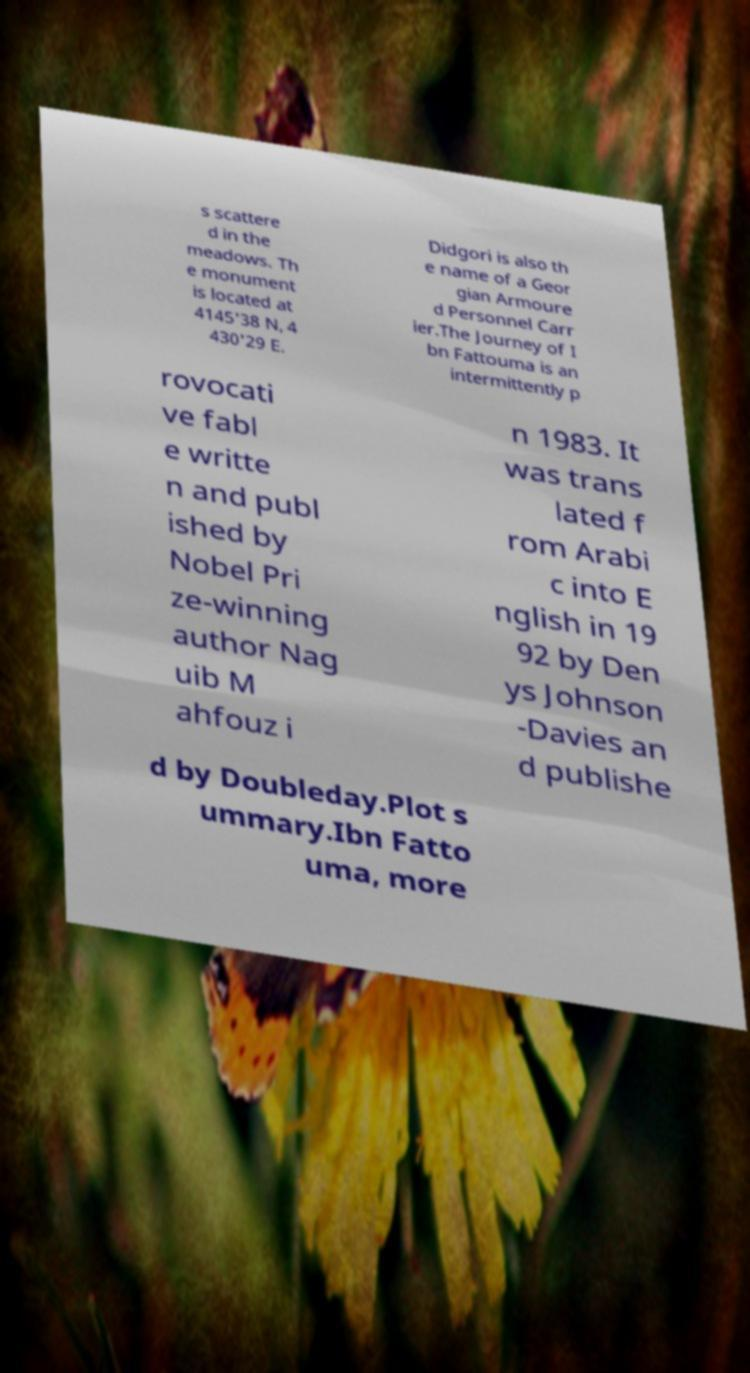Please read and relay the text visible in this image. What does it say? s scattere d in the meadows. Th e monument is located at 4145'38 N, 4 430'29 E. Didgori is also th e name of a Geor gian Armoure d Personnel Carr ier.The Journey of I bn Fattouma is an intermittently p rovocati ve fabl e writte n and publ ished by Nobel Pri ze-winning author Nag uib M ahfouz i n 1983. It was trans lated f rom Arabi c into E nglish in 19 92 by Den ys Johnson -Davies an d publishe d by Doubleday.Plot s ummary.Ibn Fatto uma, more 